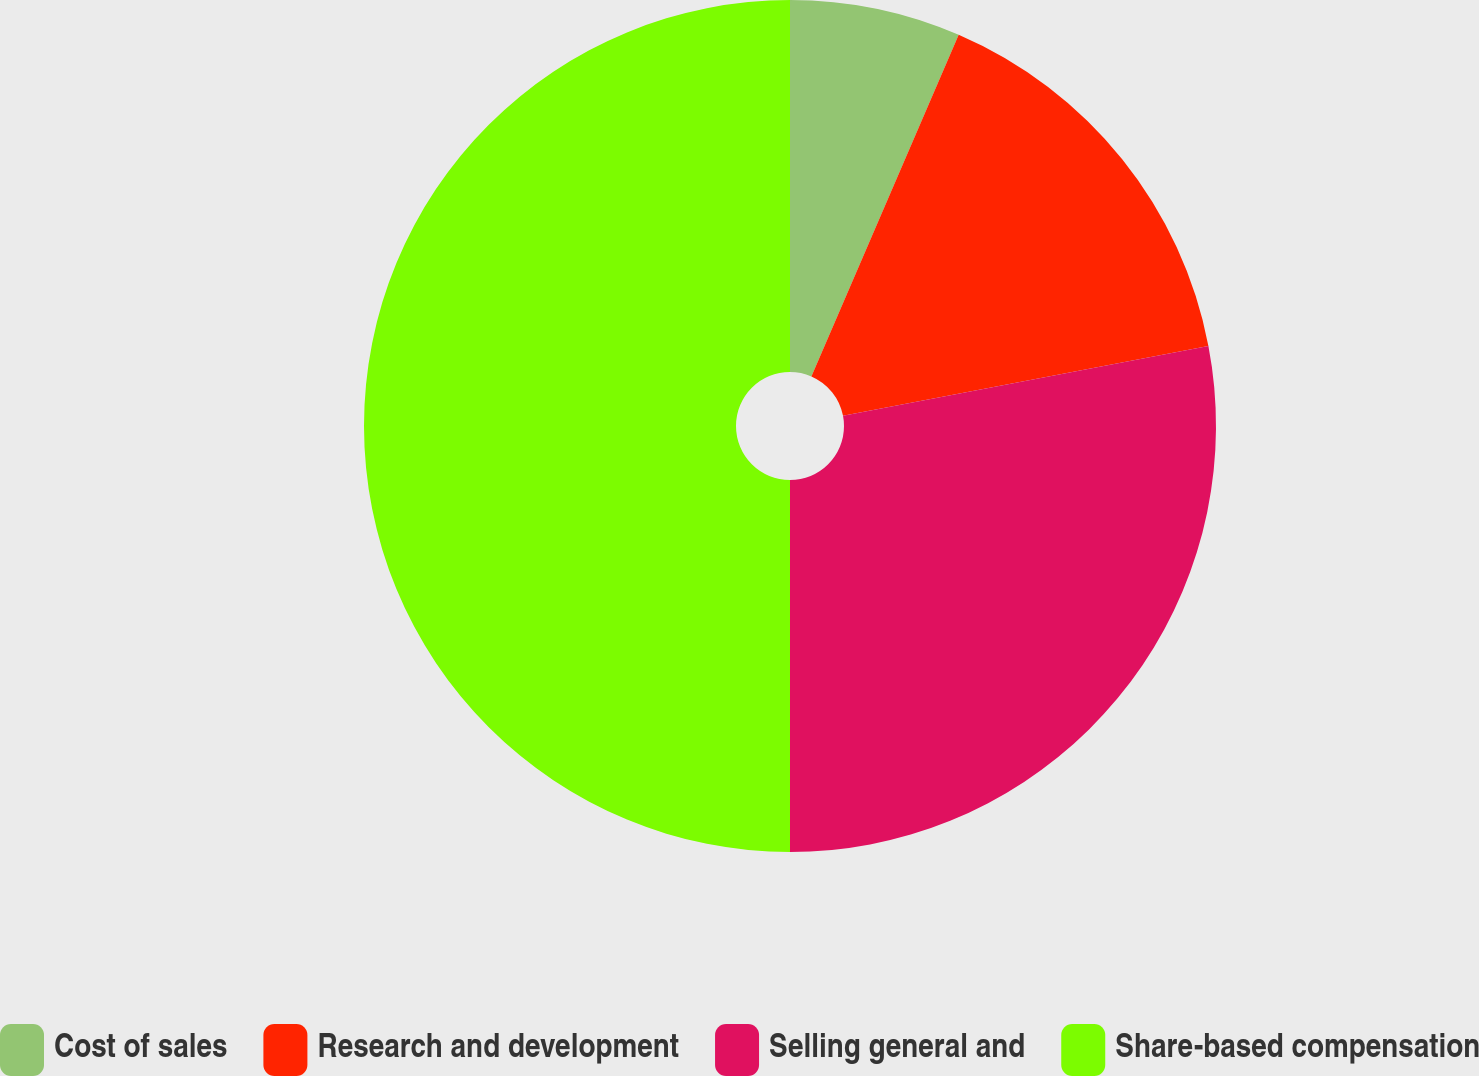Convert chart. <chart><loc_0><loc_0><loc_500><loc_500><pie_chart><fcel>Cost of sales<fcel>Research and development<fcel>Selling general and<fcel>Share-based compensation<nl><fcel>6.48%<fcel>15.51%<fcel>28.01%<fcel>50.0%<nl></chart> 